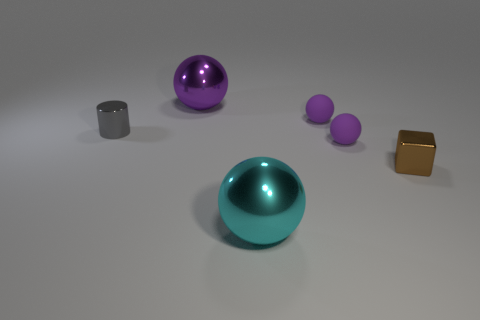Which objects in the image appear to be the most similar in shape? The cyan and purple spheres share the most similar shape - they are both perfectly round. However, the purple sphere comes in two sizes, one smaller and one larger, which are similar to each other but differ in scale. 